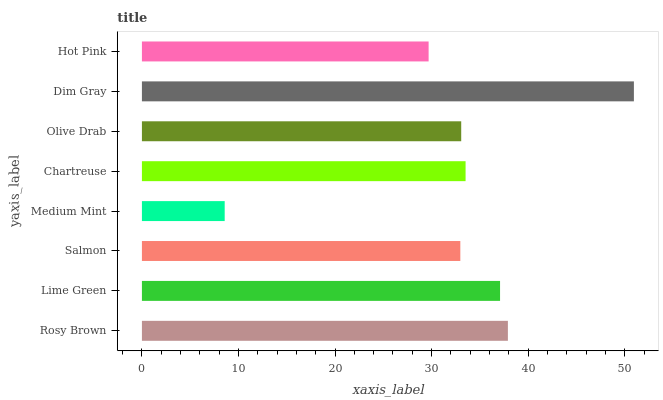Is Medium Mint the minimum?
Answer yes or no. Yes. Is Dim Gray the maximum?
Answer yes or no. Yes. Is Lime Green the minimum?
Answer yes or no. No. Is Lime Green the maximum?
Answer yes or no. No. Is Rosy Brown greater than Lime Green?
Answer yes or no. Yes. Is Lime Green less than Rosy Brown?
Answer yes or no. Yes. Is Lime Green greater than Rosy Brown?
Answer yes or no. No. Is Rosy Brown less than Lime Green?
Answer yes or no. No. Is Chartreuse the high median?
Answer yes or no. Yes. Is Olive Drab the low median?
Answer yes or no. Yes. Is Medium Mint the high median?
Answer yes or no. No. Is Chartreuse the low median?
Answer yes or no. No. 